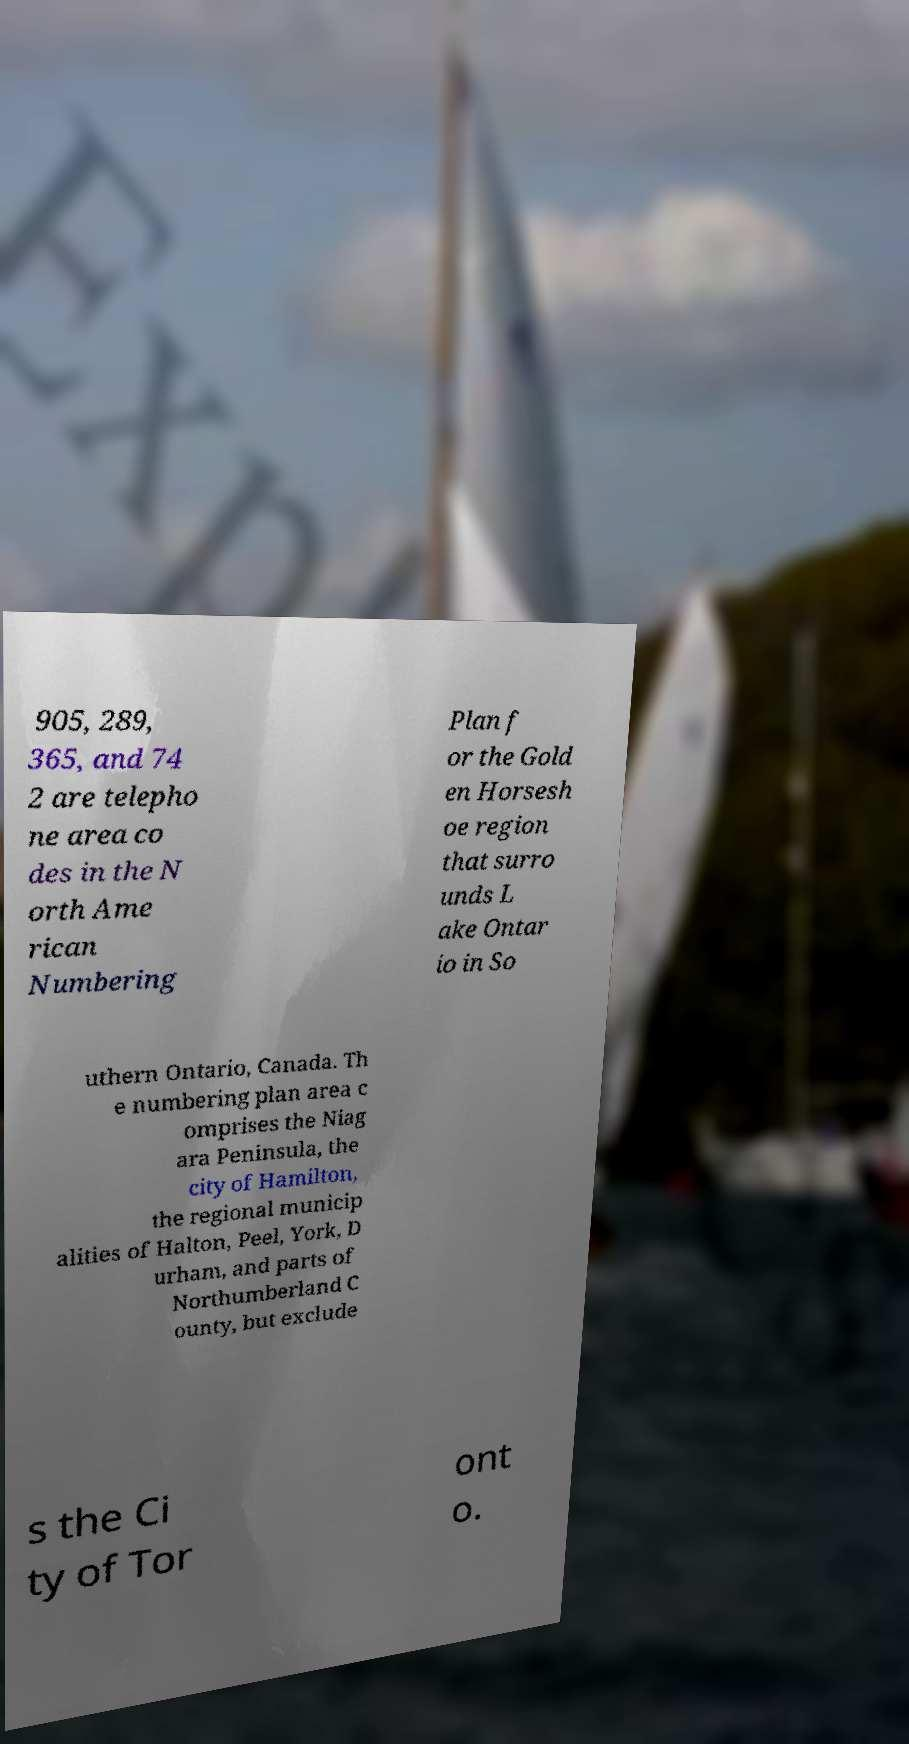Could you assist in decoding the text presented in this image and type it out clearly? 905, 289, 365, and 74 2 are telepho ne area co des in the N orth Ame rican Numbering Plan f or the Gold en Horsesh oe region that surro unds L ake Ontar io in So uthern Ontario, Canada. Th e numbering plan area c omprises the Niag ara Peninsula, the city of Hamilton, the regional municip alities of Halton, Peel, York, D urham, and parts of Northumberland C ounty, but exclude s the Ci ty of Tor ont o. 